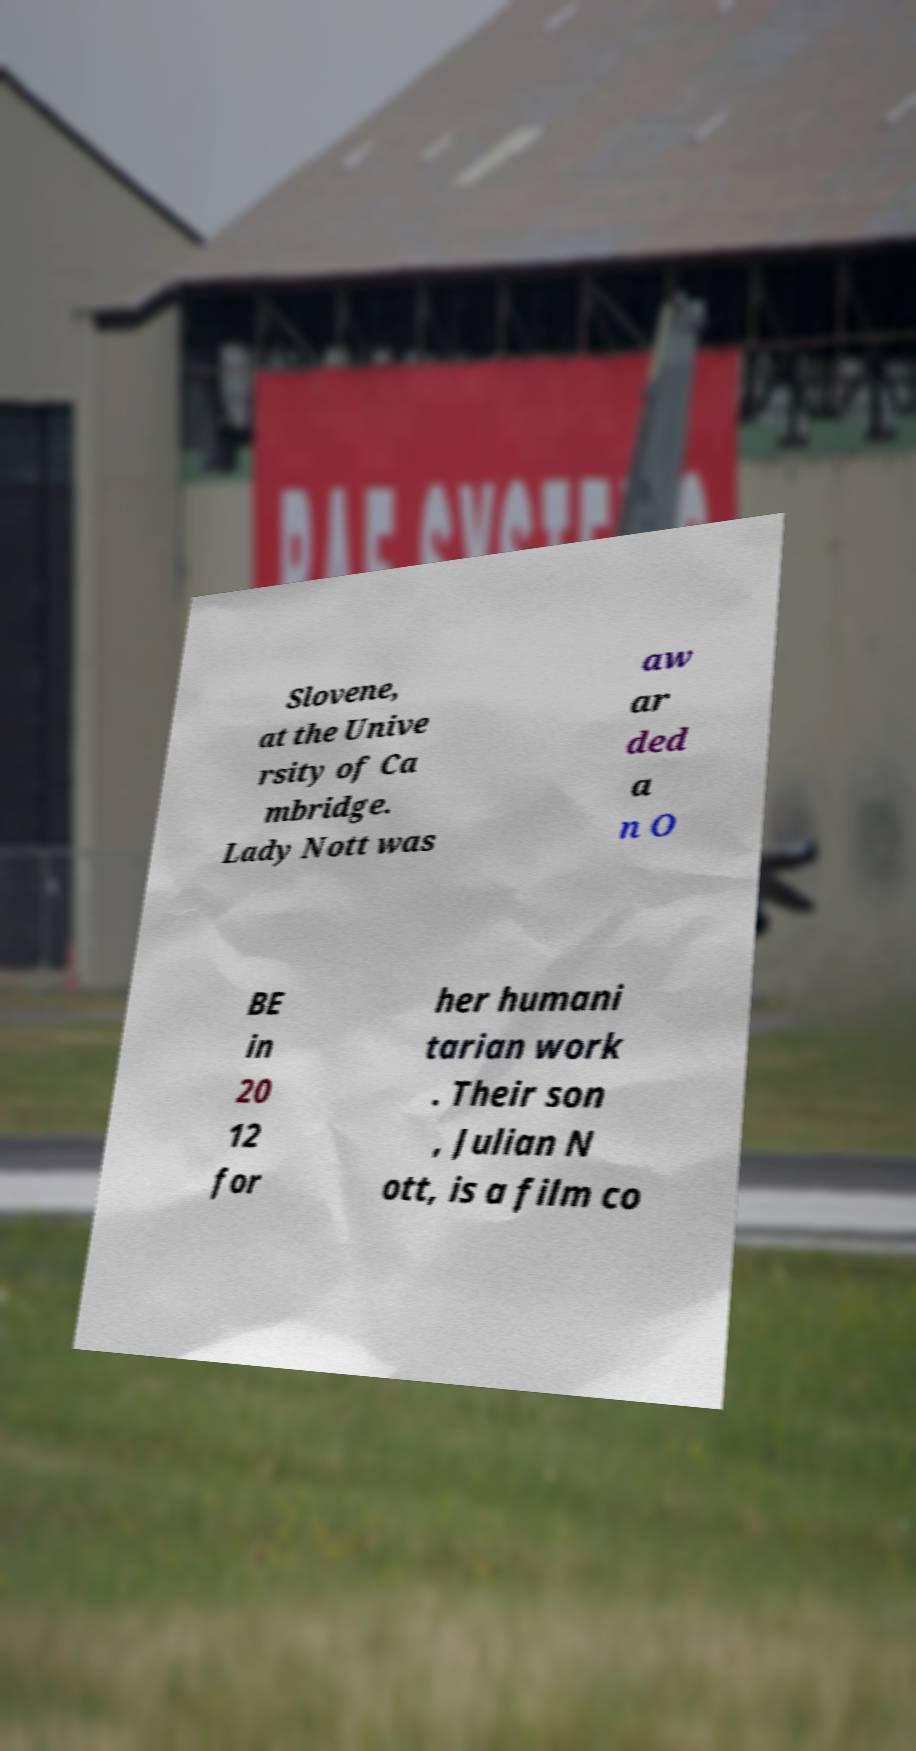Can you read and provide the text displayed in the image?This photo seems to have some interesting text. Can you extract and type it out for me? Slovene, at the Unive rsity of Ca mbridge. Lady Nott was aw ar ded a n O BE in 20 12 for her humani tarian work . Their son , Julian N ott, is a film co 